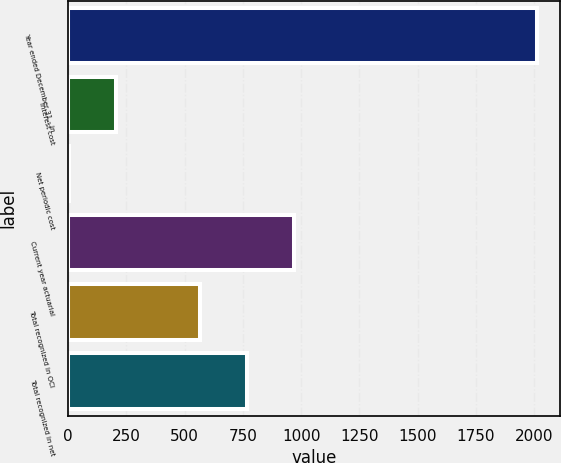Convert chart. <chart><loc_0><loc_0><loc_500><loc_500><bar_chart><fcel>Year ended December 31 - in<fcel>Interest cost<fcel>Net periodic cost<fcel>Current year actuarial<fcel>Total recognized in OCI<fcel>Total recognized in net<nl><fcel>2011<fcel>203.8<fcel>3<fcel>969.6<fcel>568<fcel>768.8<nl></chart> 